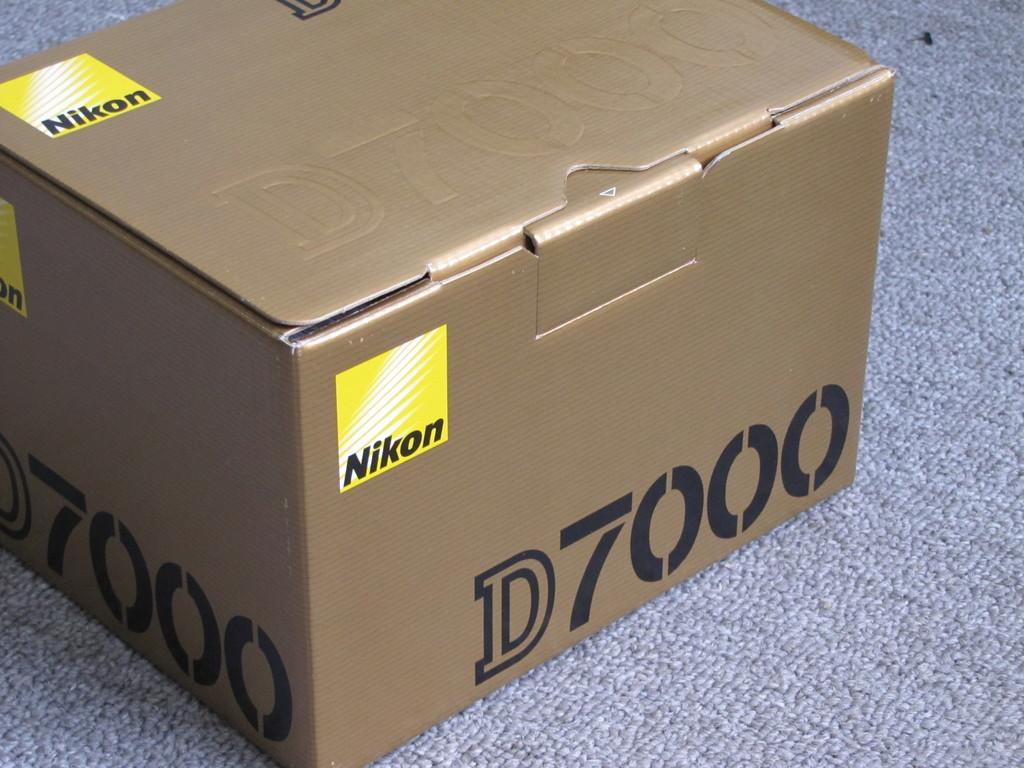<image>
Render a clear and concise summary of the photo. A cardboard Nikon box is labeled D7000 and is sitting on a carpeted floor. 